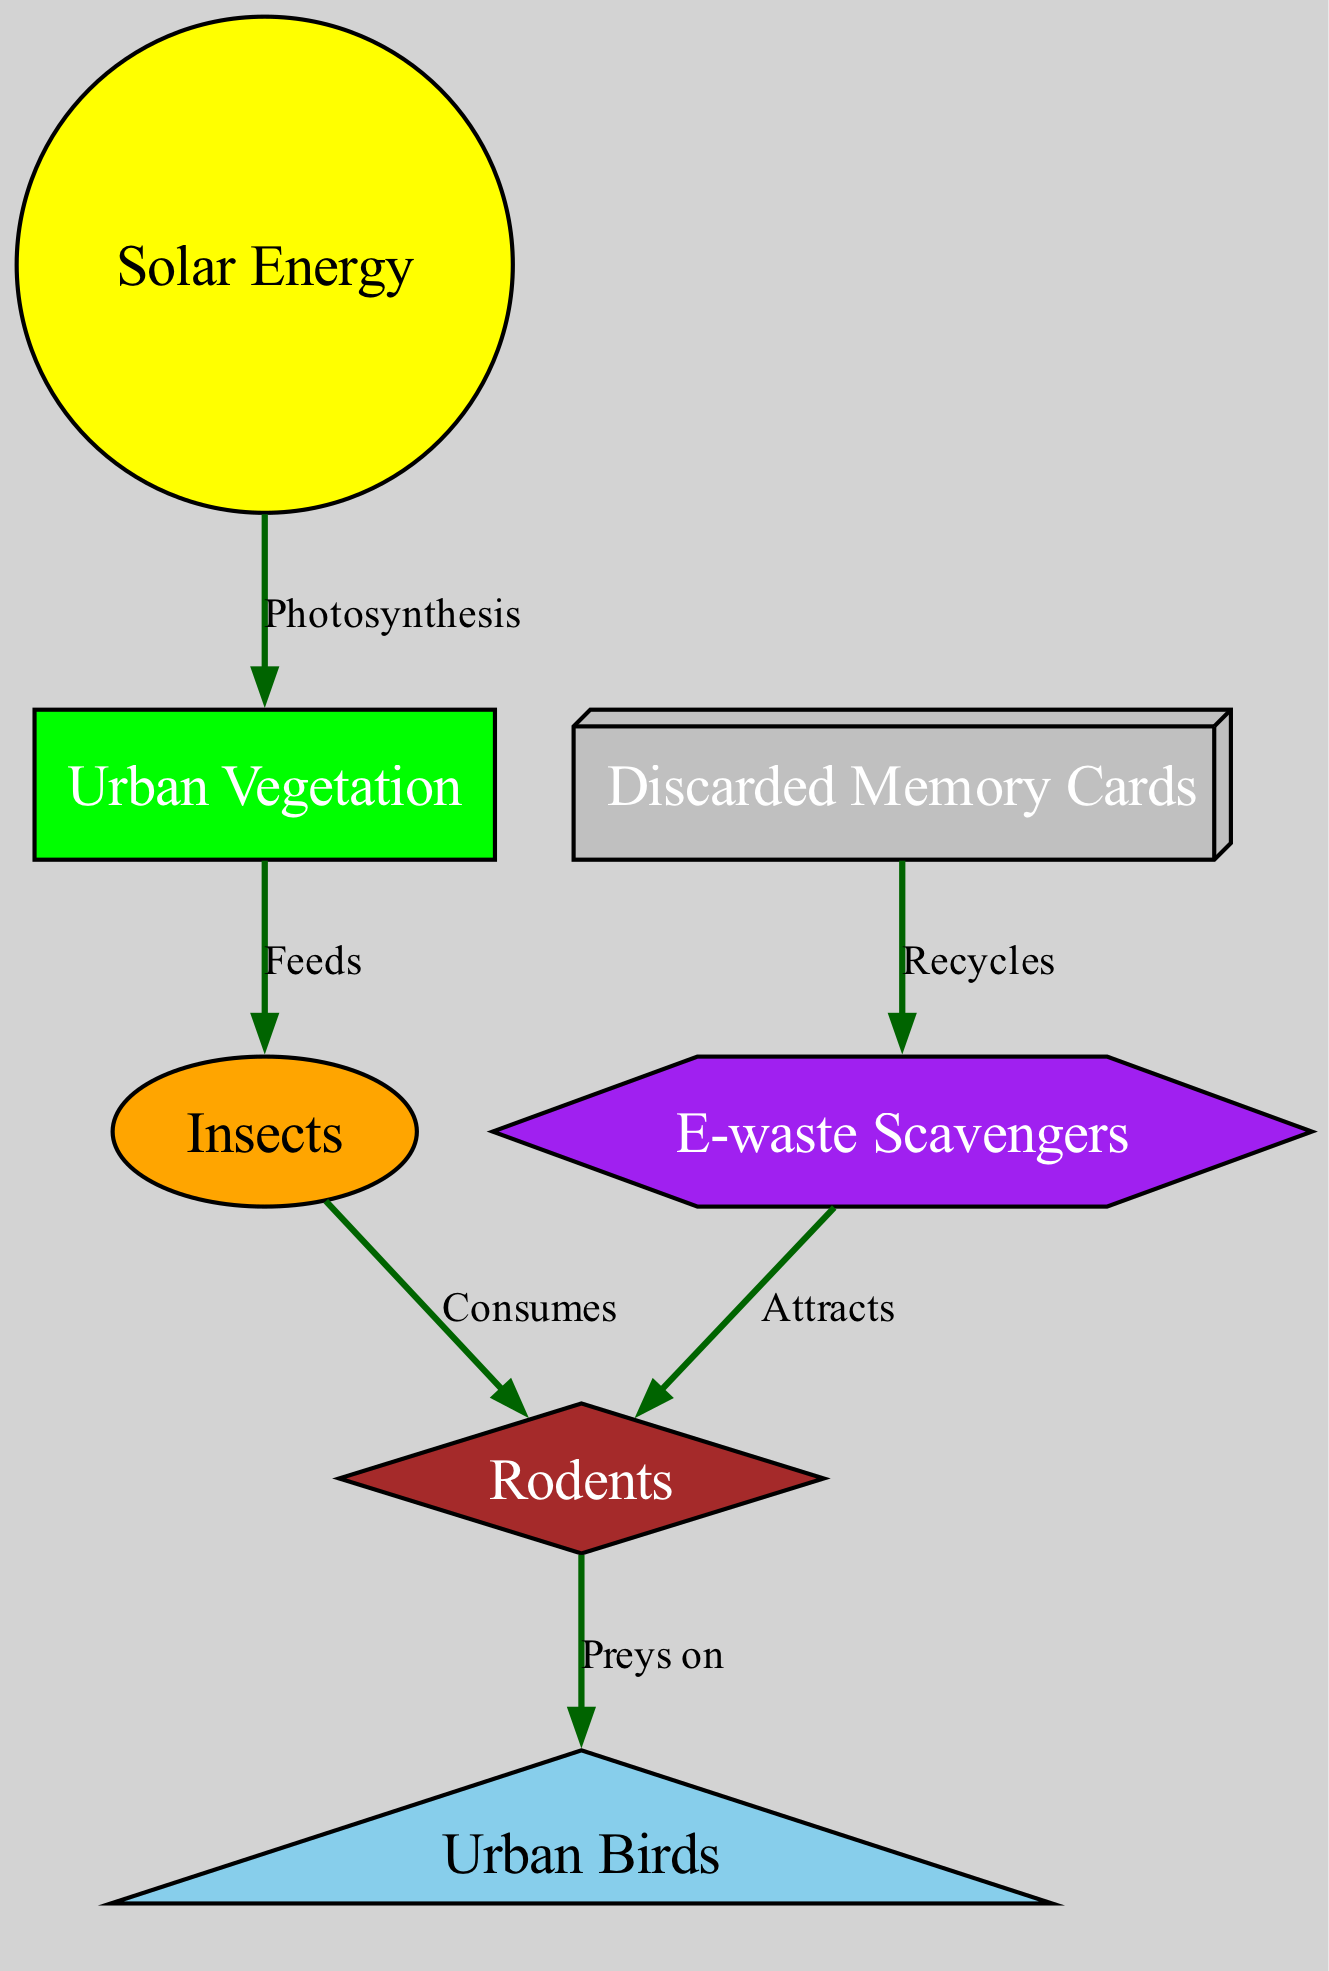What is the source of energy in this food chain? The diagram shows that the source of energy is the sun, which is labeled as "Solar Energy." This is the primary input of energy at the top of the food chain, indicating it drives the process of photosynthesis in plants.
Answer: Solar Energy How many nodes are in the diagram? By counting the unique entities displayed in the diagram, we have a total of six nodes: sun, plants, insects, rodents, birds, ewaste, and scavengers. Therefore, there are seven nodes in total.
Answer: Seven Which node is consumed by rodents? According to the edges in the diagram, rodents consume insects. This direct relationship indicates that insects are a food source for rodents, showing the flow of energy in the food chain.
Answer: Insects What do e-waste scavengers recycle? The diagram depicts that discarded memory cards are something that e-waste scavengers recycle. This relationship highlights the role of scavengers in managing digital waste in an urban environment.
Answer: Discarded Memory Cards Which organism is at the top of the food chain represented? In the diagram, the top consumer is urban birds, which prey on rodents. This shows the hierarchical structure, where birds are at the highest level among the organisms depicted.
Answer: Urban Birds How do e-waste scavengers influence the population of rodents? The diagram indicates that e-waste scavengers attract rodents. This is inferred from the direct edge flowing from scavengers to rodents, showing that the activity of scavengers has an impact on the rodent population.
Answer: Attracts What process allows urban vegetation to grow using solar energy? The edge connecting "Sun" and "Plants" signifies the process of photosynthesis. This principle allows plants to convert solar energy into chemical energy, establishing the basis of the food chain for other organisms.
Answer: Photosynthesis Which type of fauna is directly fed by urban vegetation? The diagram shows that insects are fed by urban vegetation. This direct relationship emphasizes how smaller organisms rely on plants for nourishment, making them a critical component of the urban food web.
Answer: Insects 